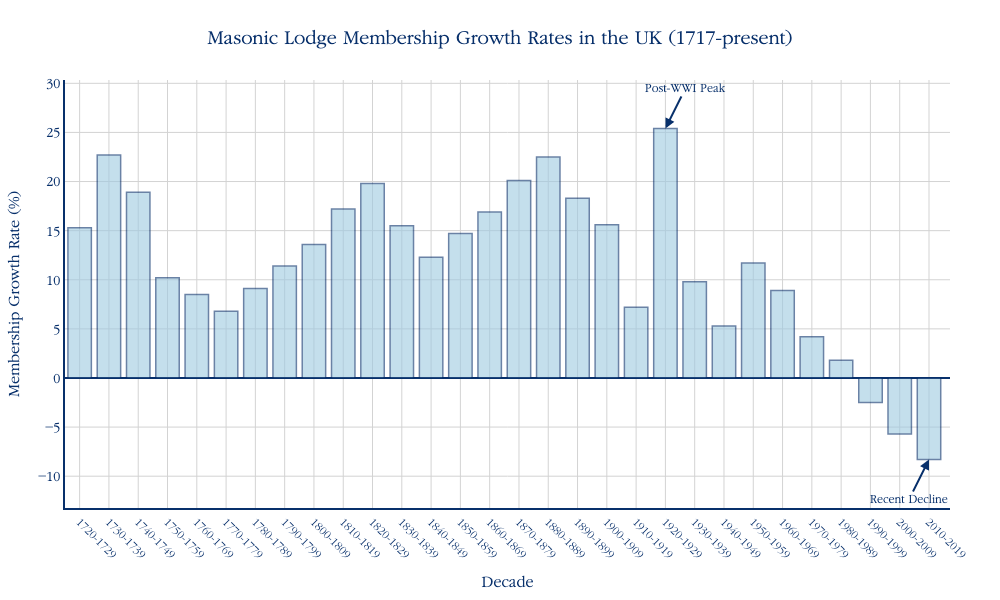What's the title of the figure? The title of the figure is written at the top and centered. It reads "Masonic Lodge Membership Growth Rates in the UK (1717-present)".
Answer: Masonic Lodge Membership Growth Rates in the UK (1717-present) What is the membership growth rate for the decade 1920-1929? The membership growth rate for each decade is shown above the bars on the x-axis. For the decade 1920-1929, it is 25.4%.
Answer: 25.4% How did the membership growth rate change from the 1720s to the 1730s? Look at the bars for the 1720-1729 and 1730-1739 decades. The rate moved from 15.3% to 22.7%. So, 22.7% - 15.3% = 7.4%.
Answer: Increased by 7.4% During which decade was the membership growth rate the highest? Identify the tallest bar in the histogram. The highest bar corresponds to the 1920-1929 decade.
Answer: 1920-1929 What is the general trend of the membership growth rate from 1950 to 2019? Observe the bars from 1950-1959 to 2010-2019. The membership growth rate starts at 11.7% and decreases, ultimately reaching -8.3% in 2010-2019.
Answer: A consistent decline Compare the growth rates of the decade after World War I (1920-1929) and the decade after World War II (1950-1959). The growth rate for 1920-1929 is 25.4%, while for 1950-1959, it is 11.7%. Comparing these values, the growth rate post-WWI is higher than post-WWII.
Answer: Post-WWI is higher By how much did the growth rate decline during the 1980s compared to the 1970s? Check the bars for the 1970-1979 and 1980-1989. For 1970-1979, the rate is 4.2%, and for 1980-1989, it is 1.8%. The difference is 4.2% - 1.8% = 2.4%.
Answer: Declined by 2.4% When did the membership growth rate first become negative? Look for the first bar that dips below the 0% line. It happens in the 1990-1999 decade, with a rate of -2.5%.
Answer: 1990-1999 What can be deduced about the growth rates before and after World War I? By comparing the bars for the decades around  WWI: 1910-1919 is 7.2%, and 1920-1929 stands at 25.4%. The post-war decade shows significant increase.
Answer: Considerable post-war increase 